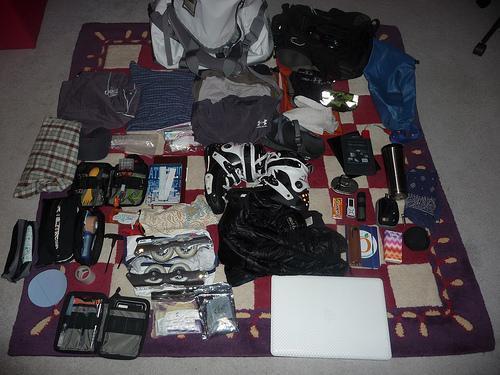How many rugs are there?
Give a very brief answer. 1. 